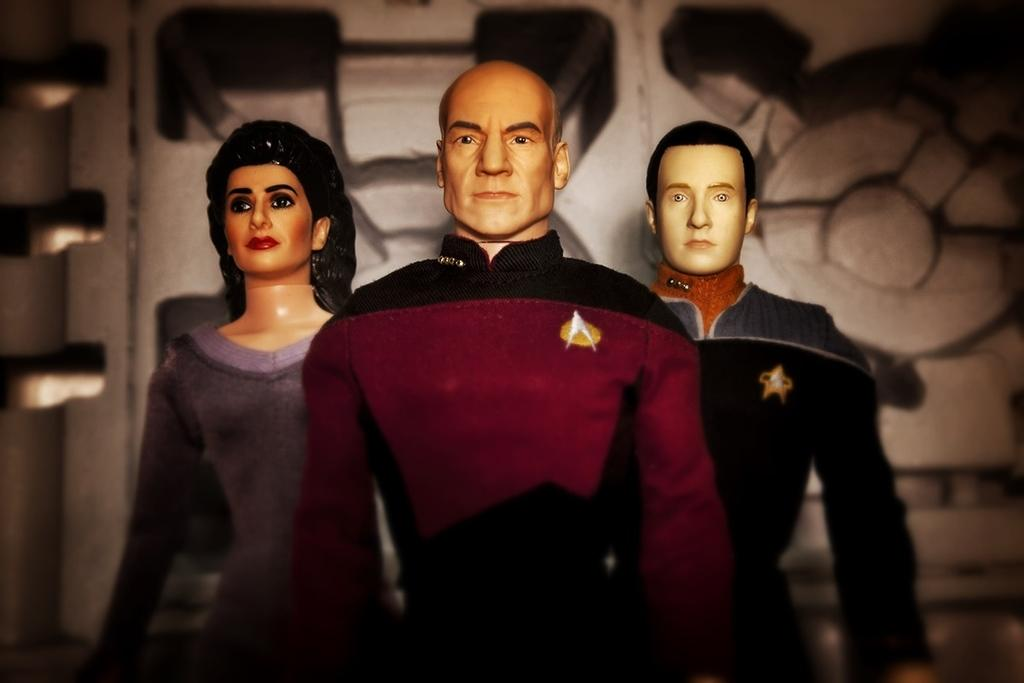How many dolls are present in the image? There are three dolls in the image. What are the dolls wearing? The dolls are wearing shirts. What can be seen in the background of the image? There is a wall in the background of the image. What year is depicted in the image? There is no specific year depicted in the image; it is a timeless scene featuring dolls wearing shirts. 